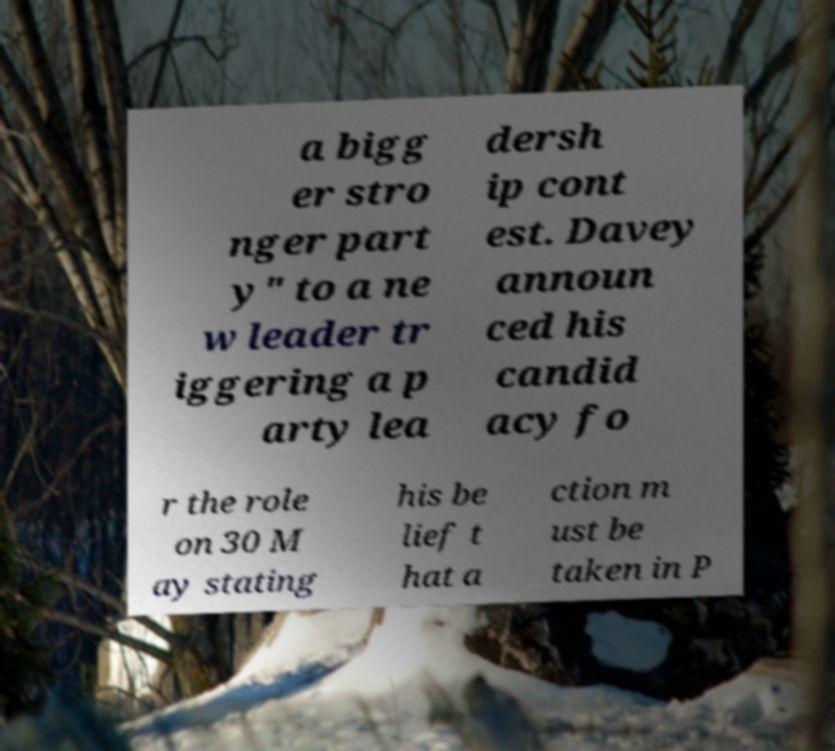For documentation purposes, I need the text within this image transcribed. Could you provide that? a bigg er stro nger part y" to a ne w leader tr iggering a p arty lea dersh ip cont est. Davey announ ced his candid acy fo r the role on 30 M ay stating his be lief t hat a ction m ust be taken in P 